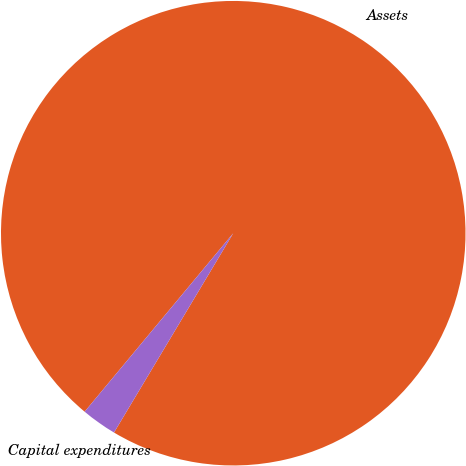<chart> <loc_0><loc_0><loc_500><loc_500><pie_chart><fcel>Assets<fcel>Capital expenditures<nl><fcel>97.53%<fcel>2.47%<nl></chart> 